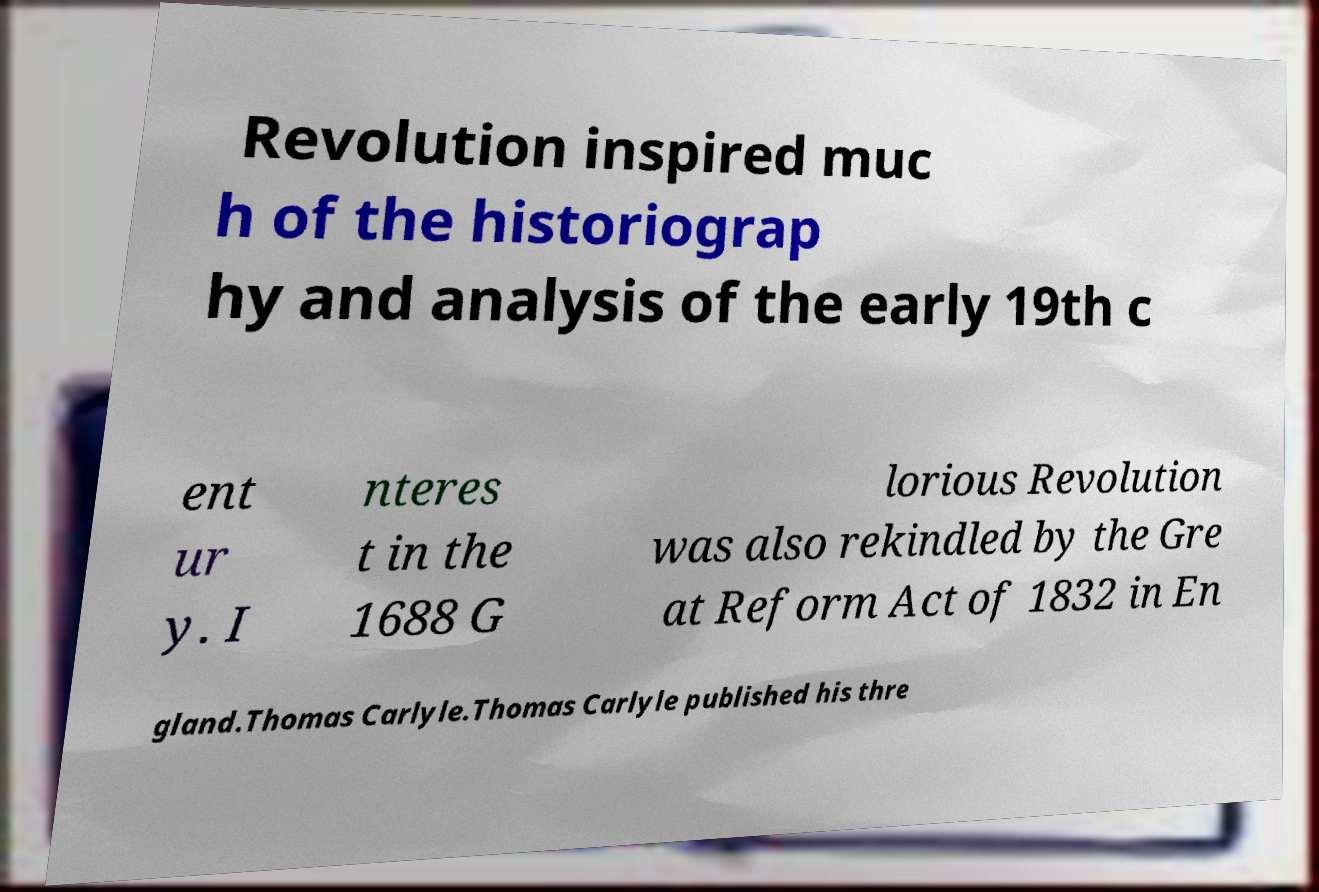Can you accurately transcribe the text from the provided image for me? Revolution inspired muc h of the historiograp hy and analysis of the early 19th c ent ur y. I nteres t in the 1688 G lorious Revolution was also rekindled by the Gre at Reform Act of 1832 in En gland.Thomas Carlyle.Thomas Carlyle published his thre 